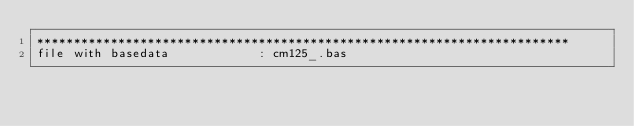Convert code to text. <code><loc_0><loc_0><loc_500><loc_500><_ObjectiveC_>************************************************************************
file with basedata            : cm125_.bas</code> 